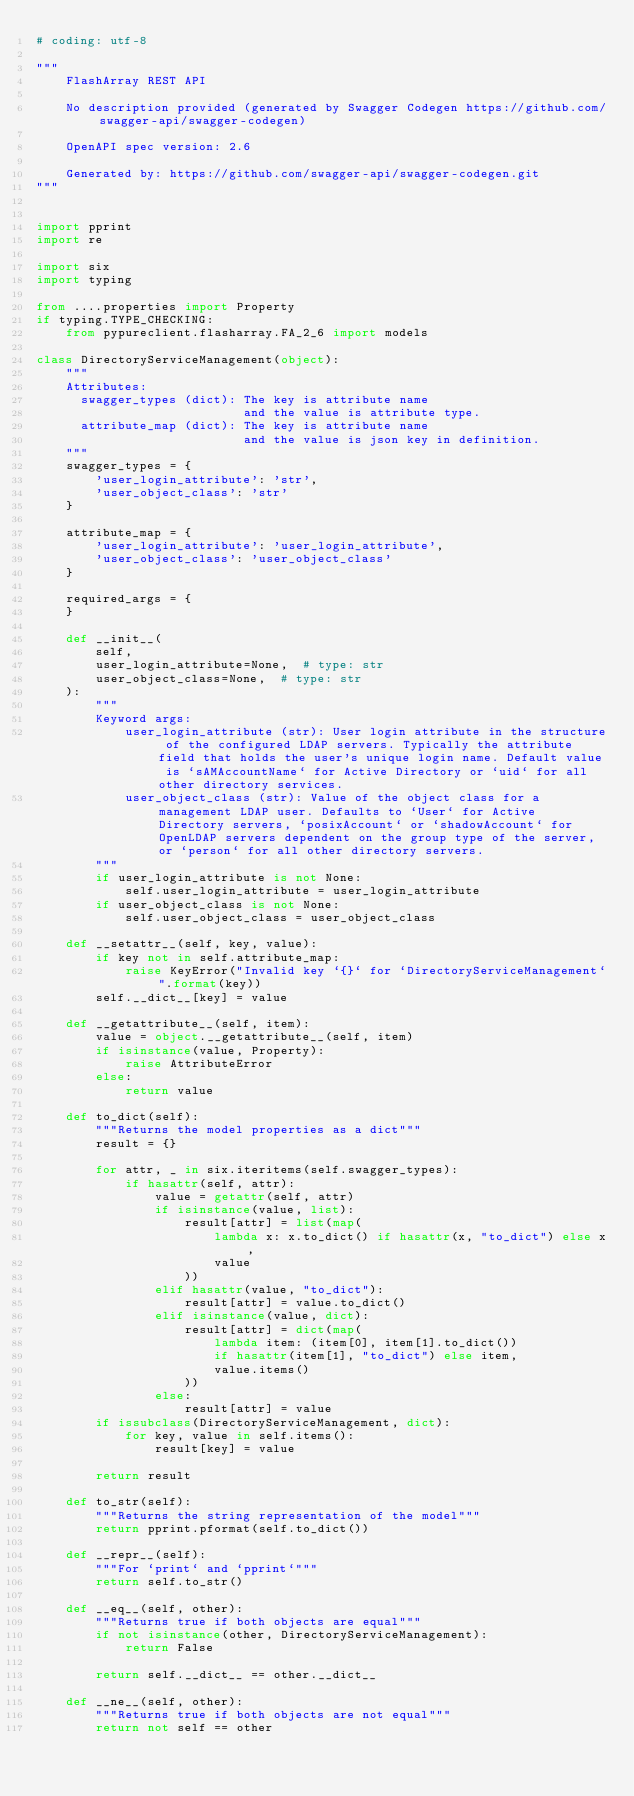Convert code to text. <code><loc_0><loc_0><loc_500><loc_500><_Python_># coding: utf-8

"""
    FlashArray REST API

    No description provided (generated by Swagger Codegen https://github.com/swagger-api/swagger-codegen)

    OpenAPI spec version: 2.6
    
    Generated by: https://github.com/swagger-api/swagger-codegen.git
"""


import pprint
import re

import six
import typing

from ....properties import Property
if typing.TYPE_CHECKING:
    from pypureclient.flasharray.FA_2_6 import models

class DirectoryServiceManagement(object):
    """
    Attributes:
      swagger_types (dict): The key is attribute name
                            and the value is attribute type.
      attribute_map (dict): The key is attribute name
                            and the value is json key in definition.
    """
    swagger_types = {
        'user_login_attribute': 'str',
        'user_object_class': 'str'
    }

    attribute_map = {
        'user_login_attribute': 'user_login_attribute',
        'user_object_class': 'user_object_class'
    }

    required_args = {
    }

    def __init__(
        self,
        user_login_attribute=None,  # type: str
        user_object_class=None,  # type: str
    ):
        """
        Keyword args:
            user_login_attribute (str): User login attribute in the structure of the configured LDAP servers. Typically the attribute field that holds the user's unique login name. Default value is `sAMAccountName` for Active Directory or `uid` for all other directory services.
            user_object_class (str): Value of the object class for a management LDAP user. Defaults to `User` for Active Directory servers, `posixAccount` or `shadowAccount` for OpenLDAP servers dependent on the group type of the server, or `person` for all other directory servers.
        """
        if user_login_attribute is not None:
            self.user_login_attribute = user_login_attribute
        if user_object_class is not None:
            self.user_object_class = user_object_class

    def __setattr__(self, key, value):
        if key not in self.attribute_map:
            raise KeyError("Invalid key `{}` for `DirectoryServiceManagement`".format(key))
        self.__dict__[key] = value

    def __getattribute__(self, item):
        value = object.__getattribute__(self, item)
        if isinstance(value, Property):
            raise AttributeError
        else:
            return value

    def to_dict(self):
        """Returns the model properties as a dict"""
        result = {}

        for attr, _ in six.iteritems(self.swagger_types):
            if hasattr(self, attr):
                value = getattr(self, attr)
                if isinstance(value, list):
                    result[attr] = list(map(
                        lambda x: x.to_dict() if hasattr(x, "to_dict") else x,
                        value
                    ))
                elif hasattr(value, "to_dict"):
                    result[attr] = value.to_dict()
                elif isinstance(value, dict):
                    result[attr] = dict(map(
                        lambda item: (item[0], item[1].to_dict())
                        if hasattr(item[1], "to_dict") else item,
                        value.items()
                    ))
                else:
                    result[attr] = value
        if issubclass(DirectoryServiceManagement, dict):
            for key, value in self.items():
                result[key] = value

        return result

    def to_str(self):
        """Returns the string representation of the model"""
        return pprint.pformat(self.to_dict())

    def __repr__(self):
        """For `print` and `pprint`"""
        return self.to_str()

    def __eq__(self, other):
        """Returns true if both objects are equal"""
        if not isinstance(other, DirectoryServiceManagement):
            return False

        return self.__dict__ == other.__dict__

    def __ne__(self, other):
        """Returns true if both objects are not equal"""
        return not self == other
</code> 